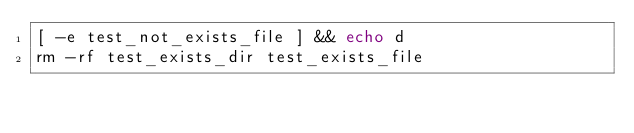<code> <loc_0><loc_0><loc_500><loc_500><_Bash_>[ -e test_not_exists_file ] && echo d
rm -rf test_exists_dir test_exists_file
</code> 